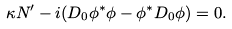Convert formula to latex. <formula><loc_0><loc_0><loc_500><loc_500>\kappa N ^ { \prime } - i ( D _ { 0 } \phi ^ { * } \phi - \phi ^ { * } D _ { 0 } \phi ) = 0 .</formula> 